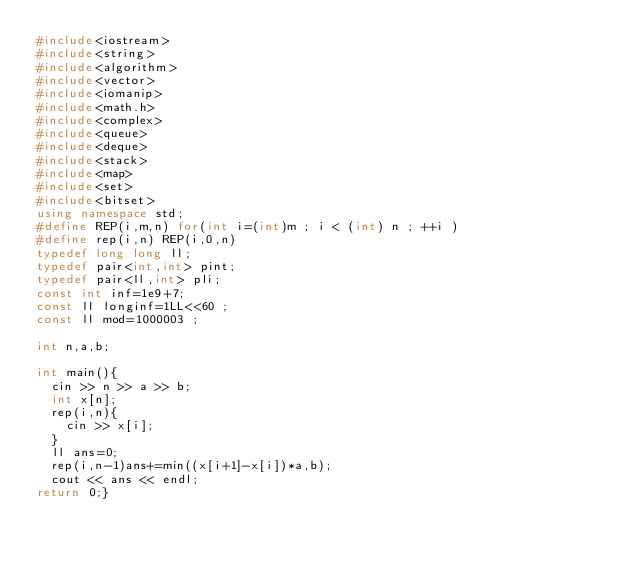<code> <loc_0><loc_0><loc_500><loc_500><_C++_>#include<iostream>
#include<string>
#include<algorithm>
#include<vector>
#include<iomanip>
#include<math.h>
#include<complex>
#include<queue>
#include<deque>
#include<stack>
#include<map>
#include<set>
#include<bitset>
using namespace std;
#define REP(i,m,n) for(int i=(int)m ; i < (int) n ; ++i )
#define rep(i,n) REP(i,0,n)
typedef long long ll;
typedef pair<int,int> pint;
typedef pair<ll,int> pli;
const int inf=1e9+7;
const ll longinf=1LL<<60 ;
const ll mod=1000003 ;

int n,a,b;

int main(){
  cin >> n >> a >> b;
  int x[n];
  rep(i,n){
    cin >> x[i];
  }
  ll ans=0;
  rep(i,n-1)ans+=min((x[i+1]-x[i])*a,b);
  cout << ans << endl;
return 0;}</code> 